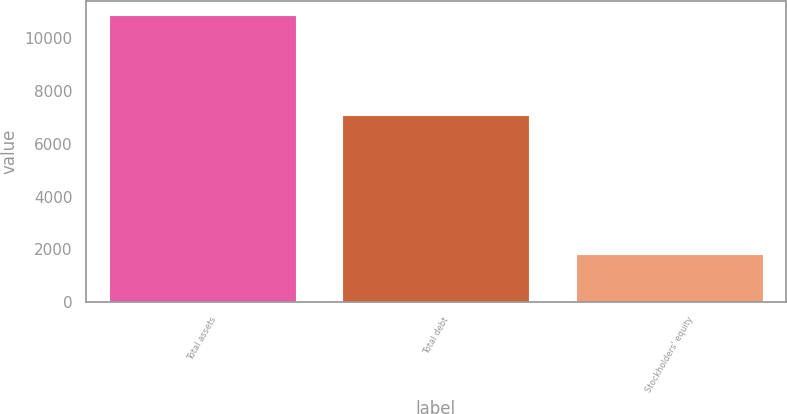Convert chart. <chart><loc_0><loc_0><loc_500><loc_500><bar_chart><fcel>Total assets<fcel>Total debt<fcel>Stockholders' equity<nl><fcel>10876<fcel>7078<fcel>1828<nl></chart> 